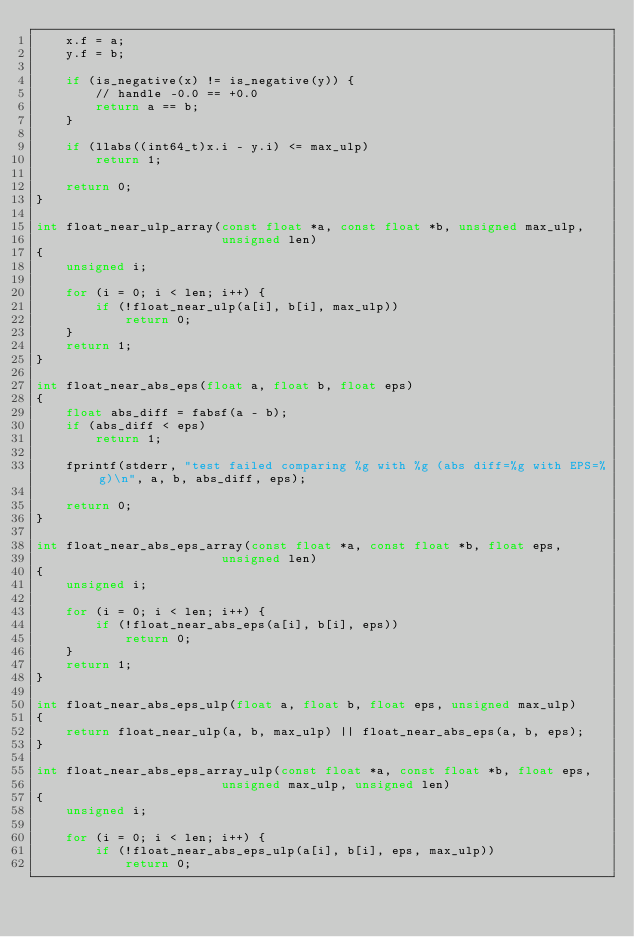Convert code to text. <code><loc_0><loc_0><loc_500><loc_500><_C_>    x.f = a;
    y.f = b;

    if (is_negative(x) != is_negative(y)) {
        // handle -0.0 == +0.0
        return a == b;
    }

    if (llabs((int64_t)x.i - y.i) <= max_ulp)
        return 1;

    return 0;
}

int float_near_ulp_array(const float *a, const float *b, unsigned max_ulp,
                         unsigned len)
{
    unsigned i;

    for (i = 0; i < len; i++) {
        if (!float_near_ulp(a[i], b[i], max_ulp))
            return 0;
    }
    return 1;
}

int float_near_abs_eps(float a, float b, float eps)
{
    float abs_diff = fabsf(a - b);
    if (abs_diff < eps)
        return 1;

    fprintf(stderr, "test failed comparing %g with %g (abs diff=%g with EPS=%g)\n", a, b, abs_diff, eps);

    return 0;
}

int float_near_abs_eps_array(const float *a, const float *b, float eps,
                         unsigned len)
{
    unsigned i;

    for (i = 0; i < len; i++) {
        if (!float_near_abs_eps(a[i], b[i], eps))
            return 0;
    }
    return 1;
}

int float_near_abs_eps_ulp(float a, float b, float eps, unsigned max_ulp)
{
    return float_near_ulp(a, b, max_ulp) || float_near_abs_eps(a, b, eps);
}

int float_near_abs_eps_array_ulp(const float *a, const float *b, float eps,
                         unsigned max_ulp, unsigned len)
{
    unsigned i;

    for (i = 0; i < len; i++) {
        if (!float_near_abs_eps_ulp(a[i], b[i], eps, max_ulp))
            return 0;</code> 